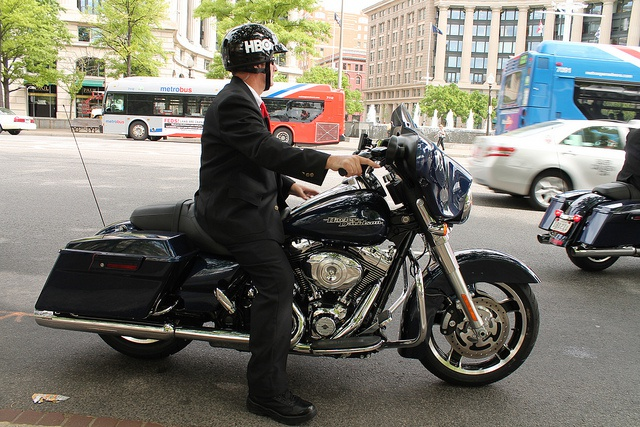Describe the objects in this image and their specific colors. I can see motorcycle in khaki, black, gray, darkgray, and lightgray tones, people in khaki, black, white, gray, and brown tones, bus in khaki, lightblue, black, and white tones, bus in khaki, white, black, salmon, and gray tones, and car in khaki, white, darkgray, gray, and black tones in this image. 